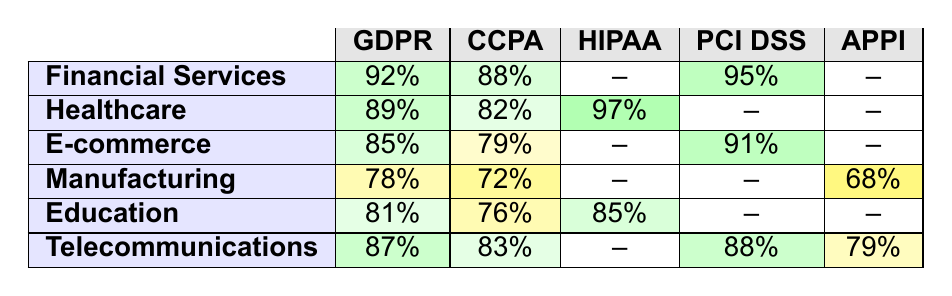What is the compliance percentage for GDPR in the Financial Services sector? The table shows that the compliance percentage for GDPR in Financial Services is listed as 92%.
Answer: 92% Which sector has the highest PCI DSS compliance percentage? By looking at the table, Financial Services has the highest PCI DSS compliance percentage at 95%.
Answer: Financial Services Is the Healthcare sector compliant with CCPA? The table indicates that Healthcare has an 82% compliance with CCPA, which means they are compliant.
Answer: Yes What is the average GDPR compliance percentage across all sectors? To find the average, we sum the GDPR compliance percentages: (92 + 89 + 85 + 78 + 81 + 87) = 512. There are 6 sectors, so the average is 512/6 = 85.33%.
Answer: 85.33% Which two sectors have the lowest CCPA compliance rates? The table shows Manufacturing with 72% and E-commerce with 79% as the lowest CCPA compliance rates.
Answer: Manufacturing and E-commerce Is there any sector that shows compliance under 70% for APPI? In the table, Manufacturing has a 68% compliance for APPI, indicating that it is under 70%.
Answer: Yes What is the difference in GDPR compliance percentage between Telecommunications and Healthcare? Telecommunications has 87% and Healthcare has 89%. The difference is 89 - 87 = 2%.
Answer: 2% In which sector does HIPAA have the highest compliance percentage? The table shows that Healthcare has the highest HIPAA compliance percentage at 97%.
Answer: Healthcare Which sector has at least a 80% compliance for all the regulations listed? Looking at the table, Financial Services has percentages of 92%, 88%, and 95% for the listed regulations. Thus, it meets the criteria.
Answer: Financial Services Can you list sectors where the compliance for CCPA is higher than 80%? The sectors with CCPA compliance higher than 80% are Financial Services (88%), Healthcare (82%), and Telecommunications (83%).
Answer: Financial Services, Healthcare, and Telecommunications 